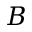<formula> <loc_0><loc_0><loc_500><loc_500>B</formula> 